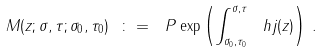<formula> <loc_0><loc_0><loc_500><loc_500>M ( z ; \sigma , \tau ; \sigma _ { 0 } , \tau _ { 0 } ) \ \colon = \ P \exp \left ( \int _ { \sigma _ { 0 } , \tau _ { 0 } } ^ { \sigma , \tau } \ h j ( z ) \right ) \, .</formula> 